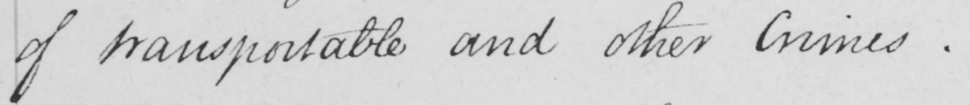What text is written in this handwritten line? of transportable and other Crimes .  _ 